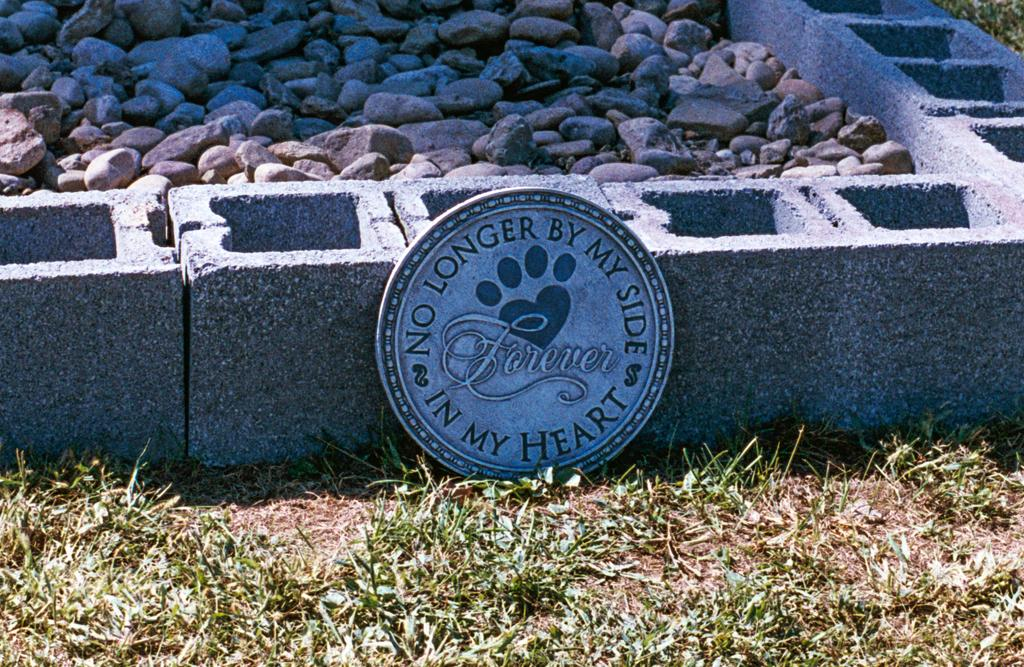What type of materials can be seen in the image? There are stones and concrete bricks in the image. What else is present in the image besides the materials? There is a memento in the image. What type of vegetation is visible in the image? Grass is present in the image. Can you see a tiger playing with a bubble in the image? There is no tiger or bubble present in the image. Is the family gathered around the memento in the image? The image does not show any family members, only the memento itself. 